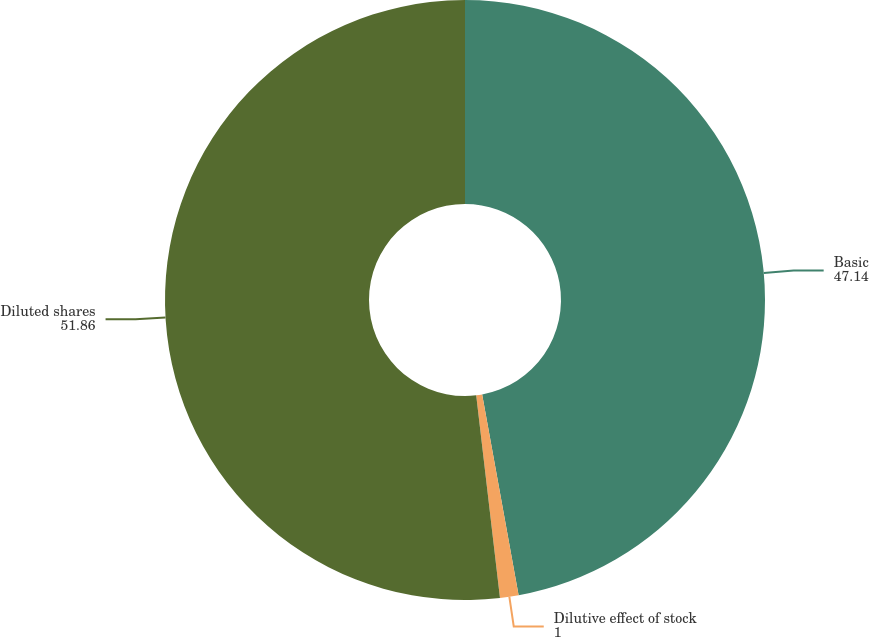<chart> <loc_0><loc_0><loc_500><loc_500><pie_chart><fcel>Basic<fcel>Dilutive effect of stock<fcel>Diluted shares<nl><fcel>47.14%<fcel>1.0%<fcel>51.86%<nl></chart> 